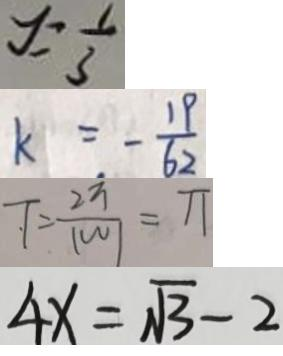<formula> <loc_0><loc_0><loc_500><loc_500>y = \frac { 1 } { 3 } 
 k = - \frac { 1 9 } { 6 2 } 
 T = \frac { 2 \pi } { \vert w \vert } = \pi 
 4 x = \sqrt { 3 } - 2</formula> 